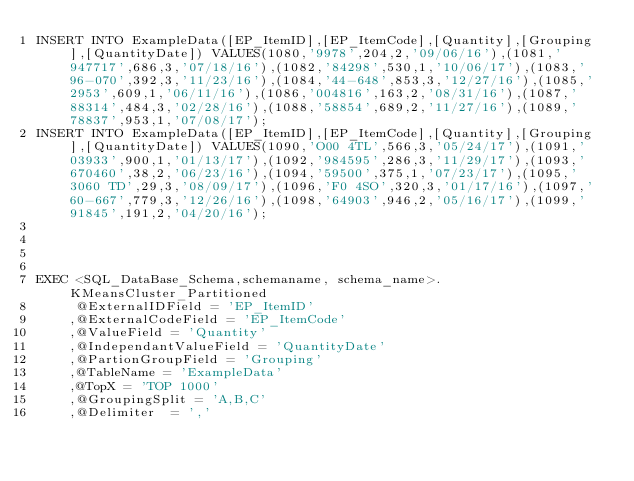Convert code to text. <code><loc_0><loc_0><loc_500><loc_500><_SQL_>INSERT INTO ExampleData([EP_ItemID],[EP_ItemCode],[Quantity],[Grouping],[QuantityDate]) VALUES(1080,'9978',204,2,'09/06/16'),(1081,'947717',686,3,'07/18/16'),(1082,'84298',530,1,'10/06/17'),(1083,'96-070',392,3,'11/23/16'),(1084,'44-648',853,3,'12/27/16'),(1085,'2953',609,1,'06/11/16'),(1086,'004816',163,2,'08/31/16'),(1087,'88314',484,3,'02/28/16'),(1088,'58854',689,2,'11/27/16'),(1089,'78837',953,1,'07/08/17');
INSERT INTO ExampleData([EP_ItemID],[EP_ItemCode],[Quantity],[Grouping],[QuantityDate]) VALUES(1090,'O00 4TL',566,3,'05/24/17'),(1091,'03933',900,1,'01/13/17'),(1092,'984595',286,3,'11/29/17'),(1093,'670460',38,2,'06/23/16'),(1094,'59500',375,1,'07/23/17'),(1095,'3060 TD',29,3,'08/09/17'),(1096,'F0 4SO',320,3,'01/17/16'),(1097,'60-667',779,3,'12/26/16'),(1098,'64903',946,2,'05/16/17'),(1099,'91845',191,2,'04/20/16');




EXEC <SQL_DataBase_Schema,schemaname, schema_name>.KMeansCluster_Partitioned
	 @ExternalIDField = 'EP_ItemID'
	,@ExternalCodeField = 'EP_ItemCode'
	,@ValueField = 'Quantity'
	,@IndependantValueField = 'QuantityDate'
	,@PartionGroupField = 'Grouping'
	,@TableName = 'ExampleData'
	,@TopX = 'TOP 1000'
	,@GroupingSplit = 'A,B,C'
	,@Delimiter	 = ','</code> 